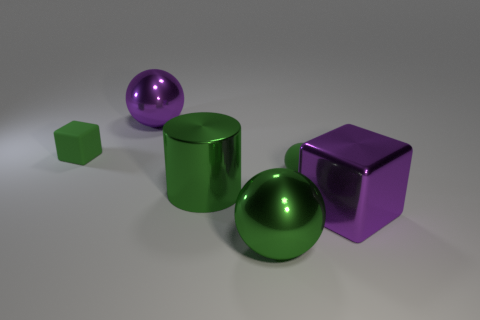What is the color of the metallic cylinder? green 